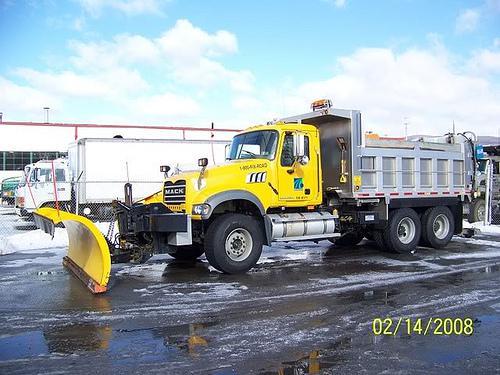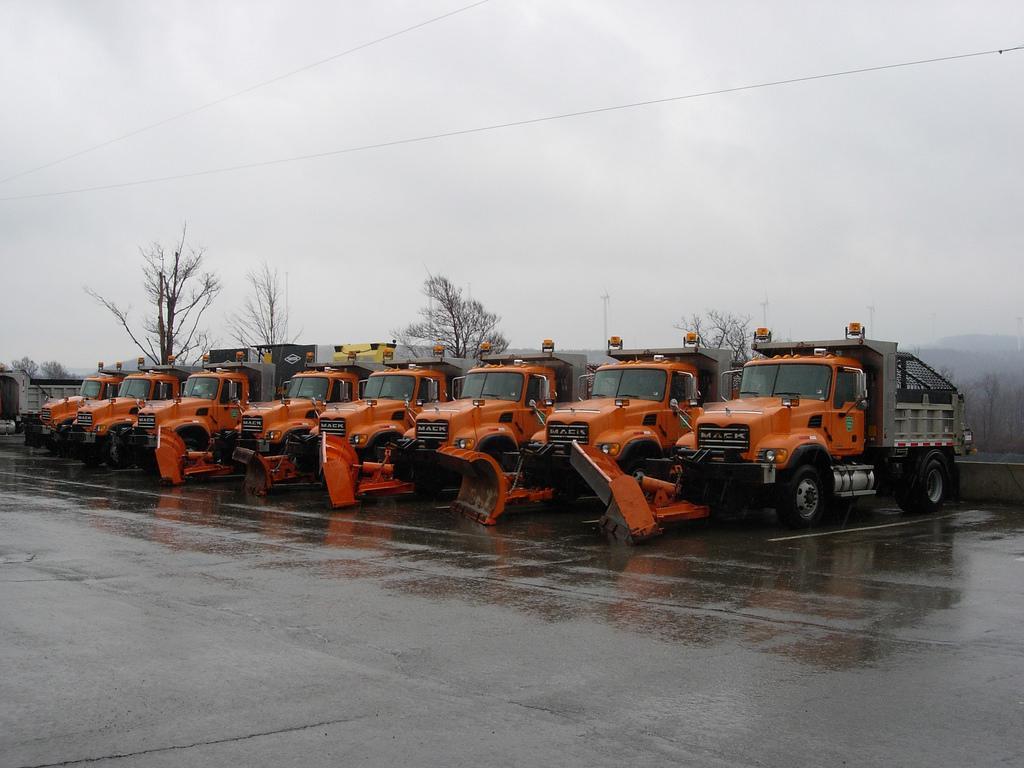The first image is the image on the left, the second image is the image on the right. Considering the images on both sides, is "There is exactly one snow plow in the right image." valid? Answer yes or no. No. The first image is the image on the left, the second image is the image on the right. For the images shown, is this caption "There is exactly one truck, with a yellow plow attached." true? Answer yes or no. Yes. 